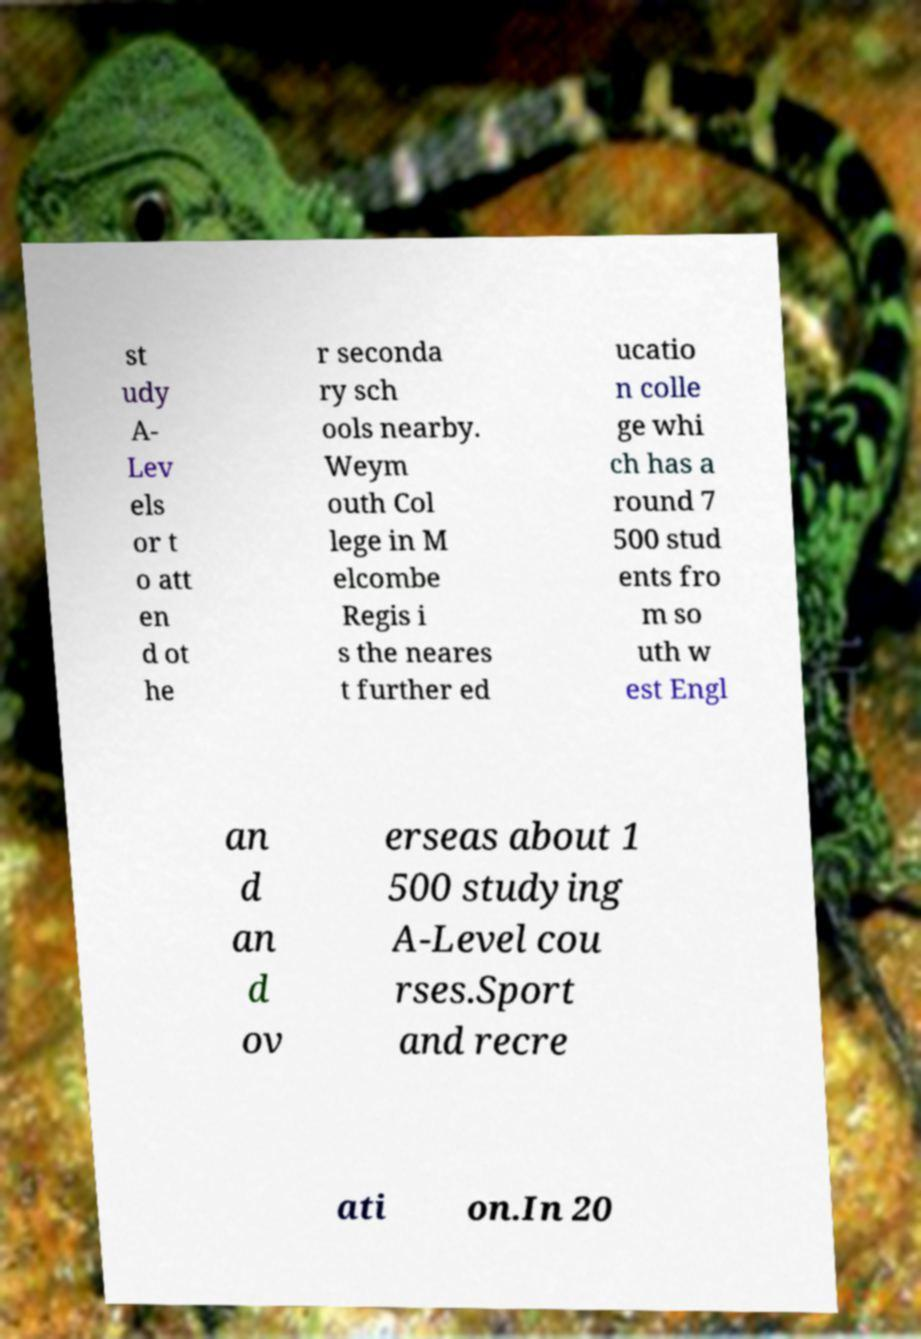Could you assist in decoding the text presented in this image and type it out clearly? st udy A- Lev els or t o att en d ot he r seconda ry sch ools nearby. Weym outh Col lege in M elcombe Regis i s the neares t further ed ucatio n colle ge whi ch has a round 7 500 stud ents fro m so uth w est Engl an d an d ov erseas about 1 500 studying A-Level cou rses.Sport and recre ati on.In 20 